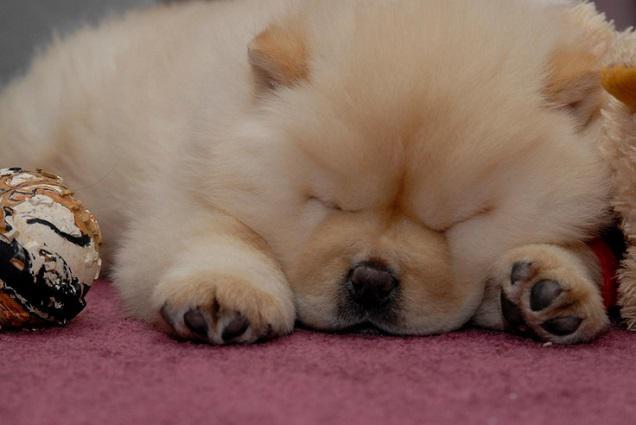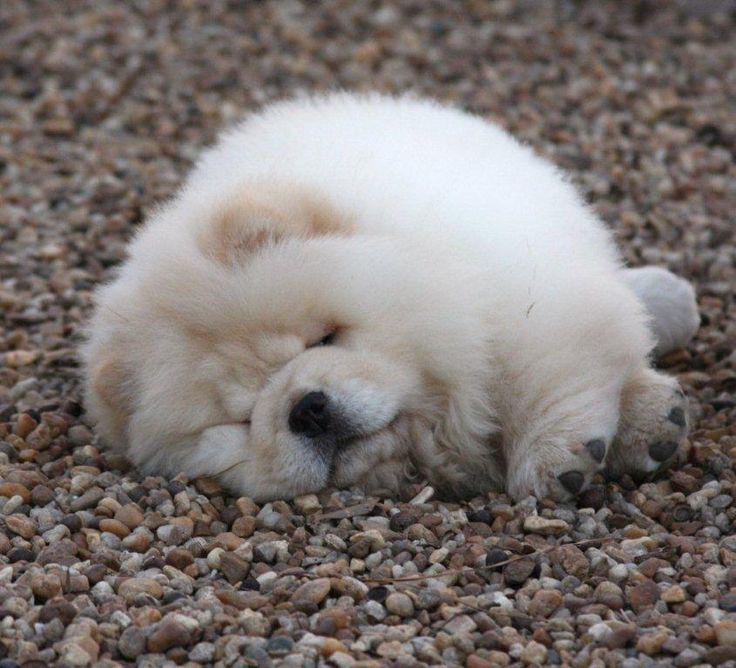The first image is the image on the left, the second image is the image on the right. Assess this claim about the two images: "There is a toy visible in one of the images.". Correct or not? Answer yes or no. Yes. The first image is the image on the left, the second image is the image on the right. Evaluate the accuracy of this statement regarding the images: "In one image in each pair a dog is sleeping on a linoleum floor.". Is it true? Answer yes or no. No. 